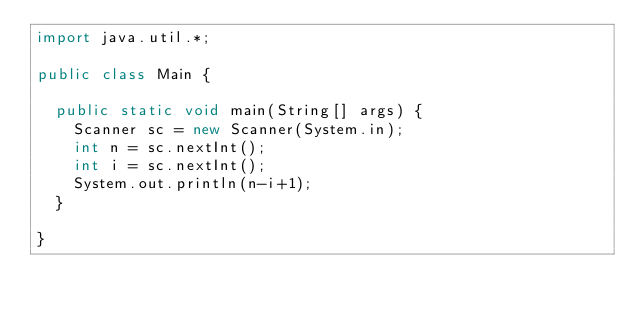<code> <loc_0><loc_0><loc_500><loc_500><_Java_>import java.util.*;

public class Main {

  public static void main(String[] args) {
    Scanner sc = new Scanner(System.in);
    int n = sc.nextInt();
    int i = sc.nextInt();
    System.out.println(n-i+1);    
  }

}
</code> 